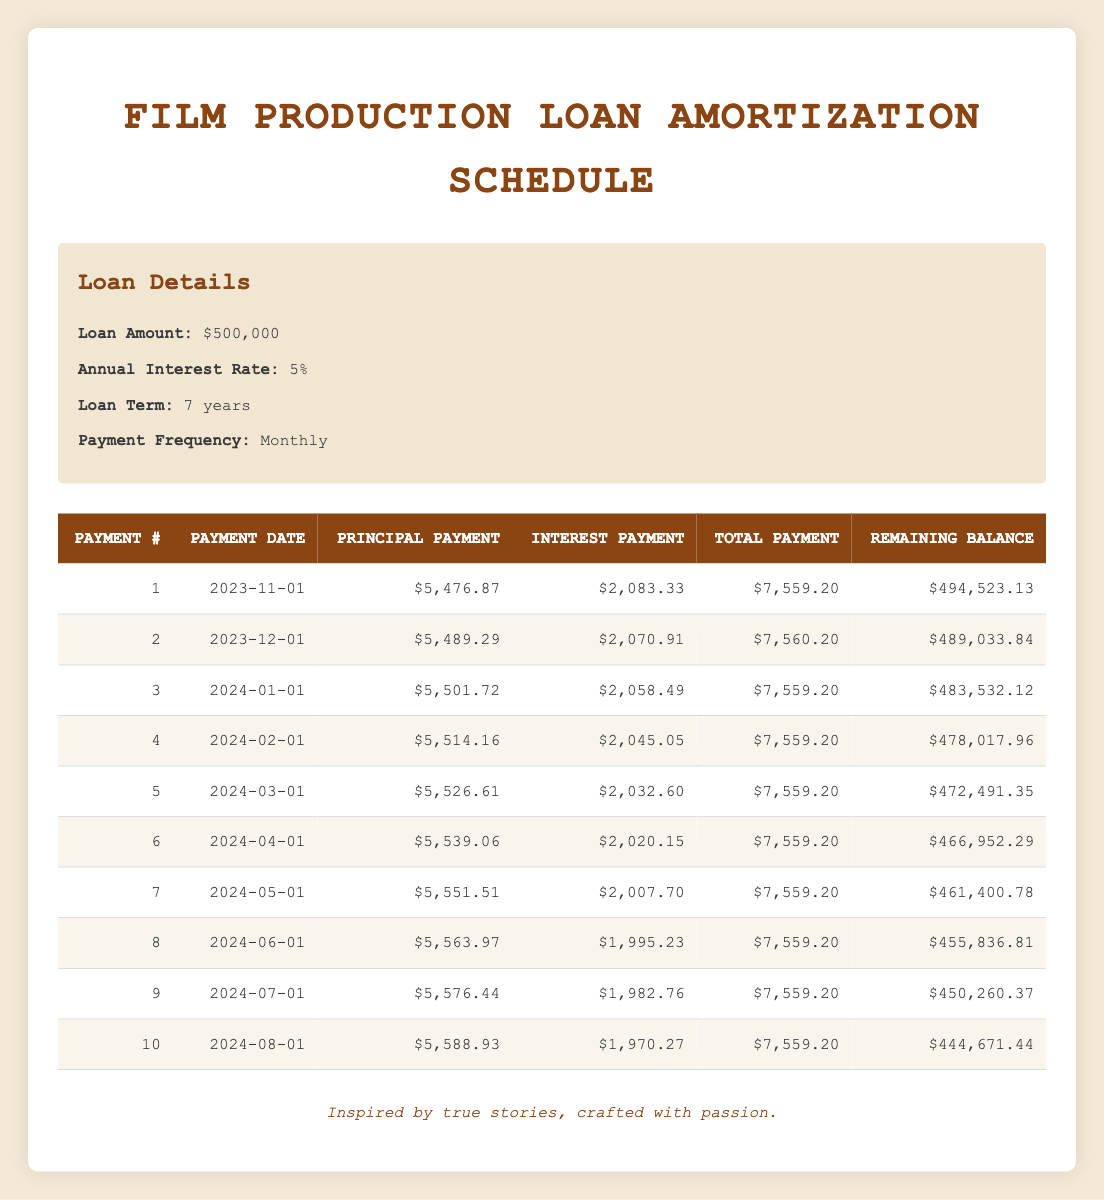What is the total payment for the first month? The first month's total payment is explicitly listed in the table under the "Total Payment" column for Payment #1, which is $7,559.20.
Answer: $7,559.20 What is the remaining balance after the fifth payment? The remaining balance after the fifth payment can be found in the table under the "Remaining Balance" column for Payment #5. It states $472,491.35.
Answer: $472,491.35 How much interest is paid in the second month? The interest payment for the second month is directly provided in the "Interest Payment" column for Payment #2, which is $2,070.91.
Answer: $2,070.91 What is the total principal paid after the first three payments? To find the total principal after the first three payments, sum the principal payments from the first three rows: $5,476.87 + $5,489.29 + $5,501.72 = $16,467.88.
Answer: $16,467.88 Is the total payment for the fourth month the same as for the first month? By checking the "Total Payment" for Payment #4, it reveals that the amount is $7,559.20, which is equal to the total payment of Payment #1, confirming it is the same.
Answer: Yes What is the average principal payment for the first ten months? To calculate the average principal payment, first add the principal payments from all ten payments and divide by ten. The sum is $5,476.87 + $5,489.29 + ... + $5,588.93 = $55,149.90. Thus, the average is $55,149.90 / 10 = $5,514.99.
Answer: $5,514.99 How much did the total interest decrease from the first to the last monthly payment shown? The total interest paid in the first payment is $2,083.33 and in the last payment (10th) it is $1,970.27. Thus, the decrease is $2,083.33 - $1,970.27 = $113.06.
Answer: $113.06 In which month is the remaining balance less than $465,000? By reviewing the "Remaining Balance" column, the remaining balance first drops below $465,000 after the sixth payment on "2024-05-01," which shows a balance of $461,400.78.
Answer: Fifth month What is the total amount paid by the end of the first year (12 payments)? To find this, sum the total payments for the first twelve months. For the first ten months, the total is $75,592.00; if payments remain constant, the total for the additional two months is $15,118.40 added for a year total of approximately $91,225.40.
Answer: $91,225.40 